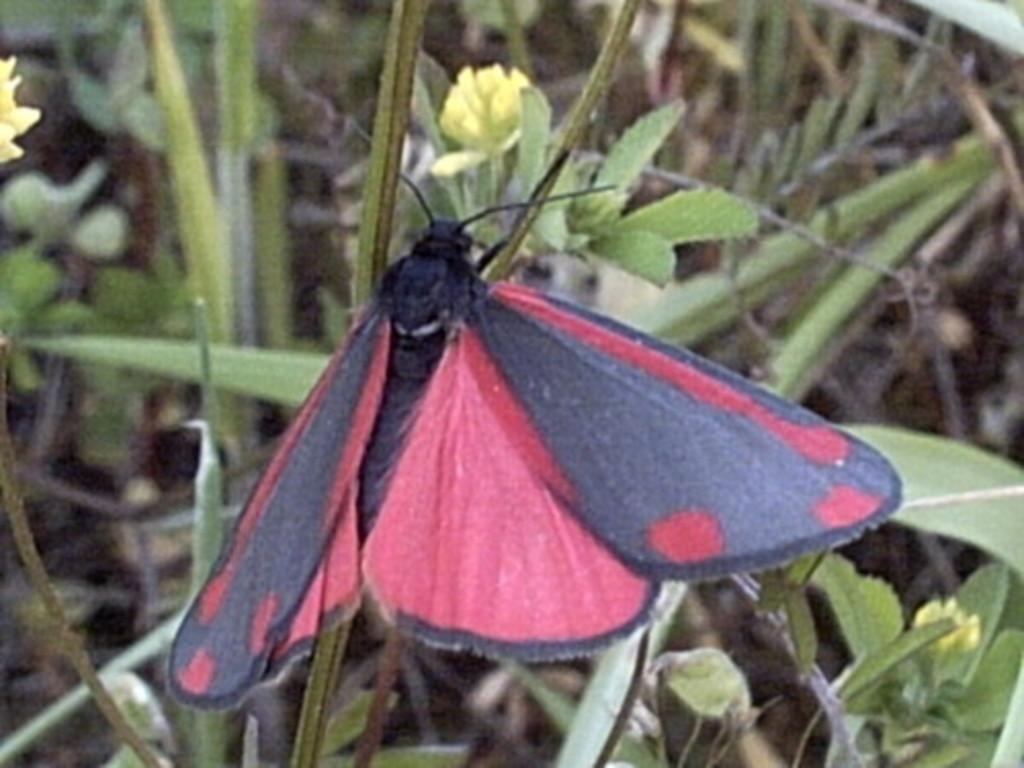What is the main subject in the center of the image? There is a butterfly in the center of the image. What can be seen in the background of the image? There are plants in the background of the image. How many servants are attending to the butterfly in the image? There are no servants present in the image; it features a butterfly and plants. What type of blood can be seen on the butterfly's wings in the image? There is no blood visible on the butterfly's wings in the image, as it is a butterfly and plants. 